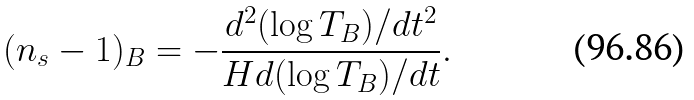<formula> <loc_0><loc_0><loc_500><loc_500>( n _ { s } - 1 ) _ { B } = - \frac { d ^ { 2 } ( \log T _ { B } ) / d t ^ { 2 } } { H d ( \log T _ { B } ) / d t } .</formula> 